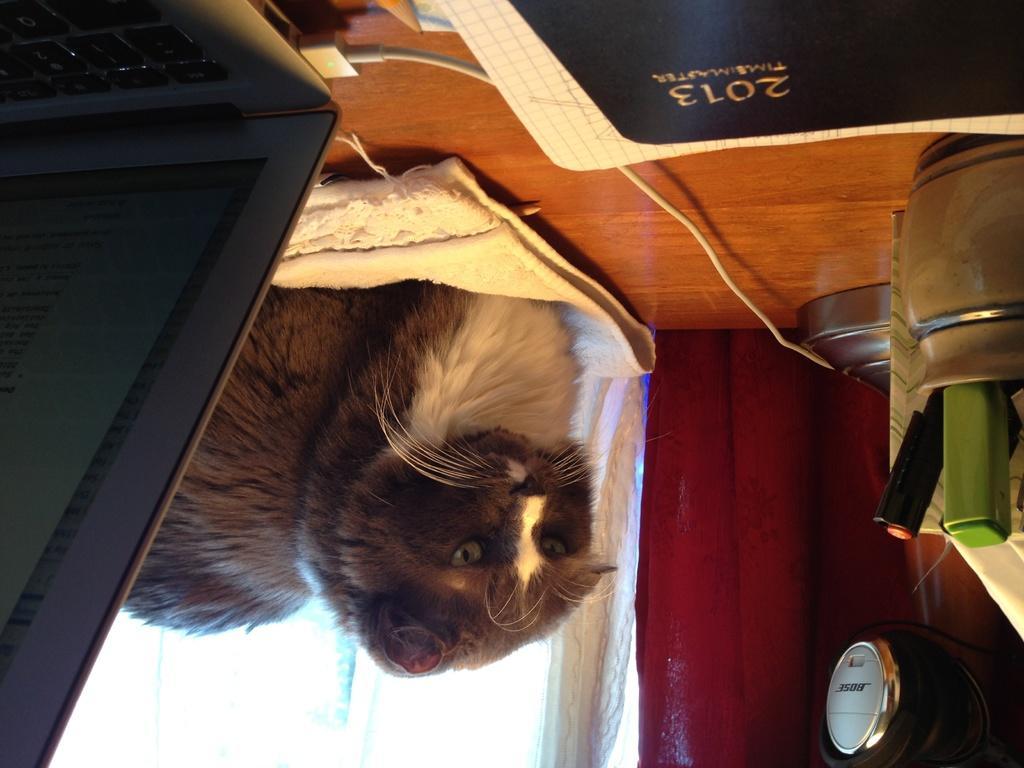Can you describe this image briefly? In this image there is a cat on the towel which is placed on the wooden table and on the table there is a laptop with a charger, a diary, paper, pencil and a steel jar with markers. In the background there is a white and the maroon curtain. 